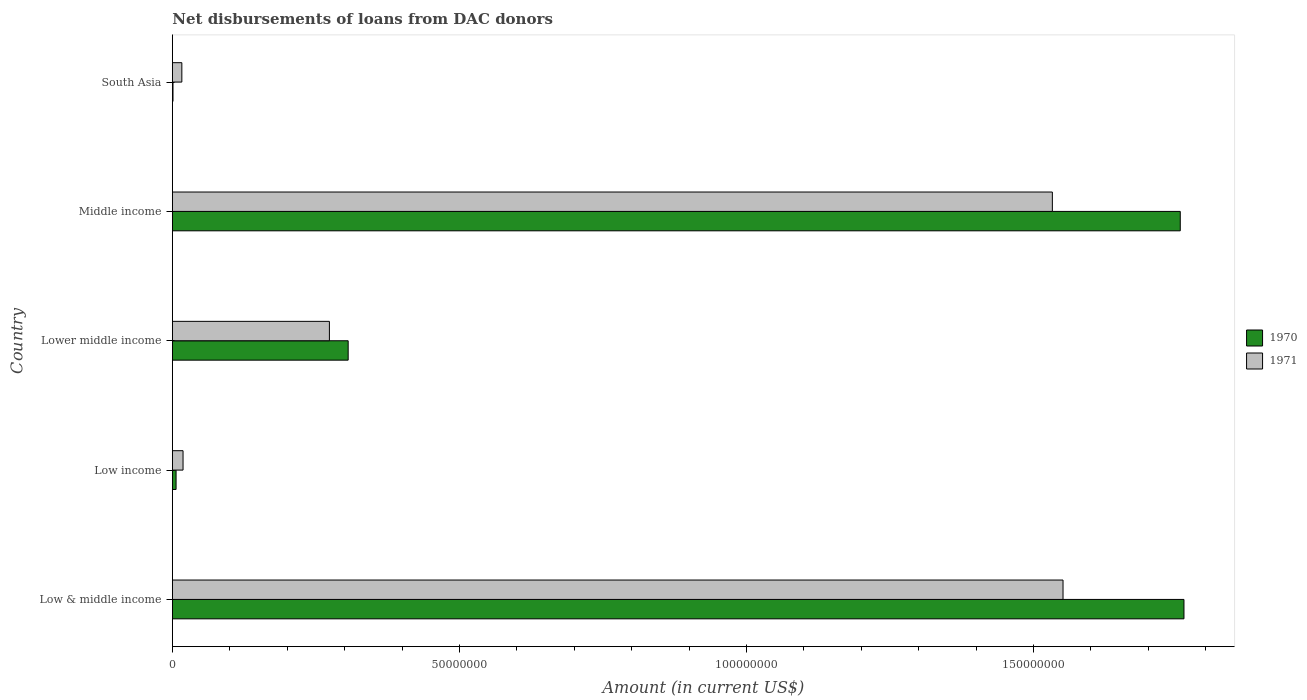How many different coloured bars are there?
Ensure brevity in your answer.  2. How many groups of bars are there?
Provide a short and direct response. 5. Are the number of bars per tick equal to the number of legend labels?
Provide a short and direct response. Yes. Are the number of bars on each tick of the Y-axis equal?
Your answer should be compact. Yes. What is the amount of loans disbursed in 1971 in South Asia?
Offer a very short reply. 1.65e+06. Across all countries, what is the maximum amount of loans disbursed in 1971?
Ensure brevity in your answer.  1.55e+08. Across all countries, what is the minimum amount of loans disbursed in 1971?
Give a very brief answer. 1.65e+06. In which country was the amount of loans disbursed in 1971 minimum?
Offer a terse response. South Asia. What is the total amount of loans disbursed in 1971 in the graph?
Your answer should be very brief. 3.39e+08. What is the difference between the amount of loans disbursed in 1971 in Low income and that in South Asia?
Offer a very short reply. 2.09e+05. What is the difference between the amount of loans disbursed in 1970 in South Asia and the amount of loans disbursed in 1971 in Lower middle income?
Make the answer very short. -2.72e+07. What is the average amount of loans disbursed in 1970 per country?
Offer a very short reply. 7.66e+07. What is the difference between the amount of loans disbursed in 1971 and amount of loans disbursed in 1970 in Lower middle income?
Offer a very short reply. -3.27e+06. In how many countries, is the amount of loans disbursed in 1971 greater than 40000000 US$?
Your response must be concise. 2. What is the ratio of the amount of loans disbursed in 1971 in Low income to that in Lower middle income?
Offer a terse response. 0.07. Is the amount of loans disbursed in 1970 in Lower middle income less than that in Middle income?
Your answer should be compact. Yes. Is the difference between the amount of loans disbursed in 1971 in Low & middle income and Middle income greater than the difference between the amount of loans disbursed in 1970 in Low & middle income and Middle income?
Give a very brief answer. Yes. What is the difference between the highest and the second highest amount of loans disbursed in 1971?
Provide a short and direct response. 1.86e+06. What is the difference between the highest and the lowest amount of loans disbursed in 1971?
Provide a short and direct response. 1.53e+08. In how many countries, is the amount of loans disbursed in 1970 greater than the average amount of loans disbursed in 1970 taken over all countries?
Keep it short and to the point. 2. What does the 2nd bar from the top in Low & middle income represents?
Make the answer very short. 1970. What does the 1st bar from the bottom in Low income represents?
Keep it short and to the point. 1970. How many bars are there?
Your answer should be very brief. 10. Are the values on the major ticks of X-axis written in scientific E-notation?
Your answer should be compact. No. Does the graph contain grids?
Your answer should be compact. No. Where does the legend appear in the graph?
Ensure brevity in your answer.  Center right. How are the legend labels stacked?
Make the answer very short. Vertical. What is the title of the graph?
Offer a very short reply. Net disbursements of loans from DAC donors. What is the label or title of the Y-axis?
Offer a very short reply. Country. What is the Amount (in current US$) of 1970 in Low & middle income?
Your answer should be compact. 1.76e+08. What is the Amount (in current US$) of 1971 in Low & middle income?
Your response must be concise. 1.55e+08. What is the Amount (in current US$) of 1970 in Low income?
Your response must be concise. 6.47e+05. What is the Amount (in current US$) of 1971 in Low income?
Provide a short and direct response. 1.86e+06. What is the Amount (in current US$) in 1970 in Lower middle income?
Offer a terse response. 3.06e+07. What is the Amount (in current US$) in 1971 in Lower middle income?
Your answer should be compact. 2.74e+07. What is the Amount (in current US$) of 1970 in Middle income?
Make the answer very short. 1.76e+08. What is the Amount (in current US$) in 1971 in Middle income?
Your answer should be very brief. 1.53e+08. What is the Amount (in current US$) of 1970 in South Asia?
Provide a succinct answer. 1.09e+05. What is the Amount (in current US$) in 1971 in South Asia?
Your response must be concise. 1.65e+06. Across all countries, what is the maximum Amount (in current US$) in 1970?
Your response must be concise. 1.76e+08. Across all countries, what is the maximum Amount (in current US$) of 1971?
Give a very brief answer. 1.55e+08. Across all countries, what is the minimum Amount (in current US$) of 1970?
Your response must be concise. 1.09e+05. Across all countries, what is the minimum Amount (in current US$) in 1971?
Your answer should be compact. 1.65e+06. What is the total Amount (in current US$) of 1970 in the graph?
Give a very brief answer. 3.83e+08. What is the total Amount (in current US$) in 1971 in the graph?
Provide a short and direct response. 3.39e+08. What is the difference between the Amount (in current US$) in 1970 in Low & middle income and that in Low income?
Ensure brevity in your answer.  1.76e+08. What is the difference between the Amount (in current US$) of 1971 in Low & middle income and that in Low income?
Your answer should be very brief. 1.53e+08. What is the difference between the Amount (in current US$) in 1970 in Low & middle income and that in Lower middle income?
Make the answer very short. 1.46e+08. What is the difference between the Amount (in current US$) of 1971 in Low & middle income and that in Lower middle income?
Keep it short and to the point. 1.28e+08. What is the difference between the Amount (in current US$) in 1970 in Low & middle income and that in Middle income?
Provide a succinct answer. 6.47e+05. What is the difference between the Amount (in current US$) in 1971 in Low & middle income and that in Middle income?
Keep it short and to the point. 1.86e+06. What is the difference between the Amount (in current US$) in 1970 in Low & middle income and that in South Asia?
Offer a very short reply. 1.76e+08. What is the difference between the Amount (in current US$) of 1971 in Low & middle income and that in South Asia?
Provide a succinct answer. 1.53e+08. What is the difference between the Amount (in current US$) in 1970 in Low income and that in Lower middle income?
Your response must be concise. -3.00e+07. What is the difference between the Amount (in current US$) in 1971 in Low income and that in Lower middle income?
Offer a terse response. -2.55e+07. What is the difference between the Amount (in current US$) in 1970 in Low income and that in Middle income?
Ensure brevity in your answer.  -1.75e+08. What is the difference between the Amount (in current US$) of 1971 in Low income and that in Middle income?
Give a very brief answer. -1.51e+08. What is the difference between the Amount (in current US$) of 1970 in Low income and that in South Asia?
Ensure brevity in your answer.  5.38e+05. What is the difference between the Amount (in current US$) of 1971 in Low income and that in South Asia?
Provide a short and direct response. 2.09e+05. What is the difference between the Amount (in current US$) in 1970 in Lower middle income and that in Middle income?
Offer a terse response. -1.45e+08. What is the difference between the Amount (in current US$) of 1971 in Lower middle income and that in Middle income?
Your answer should be compact. -1.26e+08. What is the difference between the Amount (in current US$) of 1970 in Lower middle income and that in South Asia?
Offer a very short reply. 3.05e+07. What is the difference between the Amount (in current US$) of 1971 in Lower middle income and that in South Asia?
Your answer should be very brief. 2.57e+07. What is the difference between the Amount (in current US$) in 1970 in Middle income and that in South Asia?
Offer a terse response. 1.75e+08. What is the difference between the Amount (in current US$) in 1971 in Middle income and that in South Asia?
Offer a very short reply. 1.52e+08. What is the difference between the Amount (in current US$) of 1970 in Low & middle income and the Amount (in current US$) of 1971 in Low income?
Provide a succinct answer. 1.74e+08. What is the difference between the Amount (in current US$) of 1970 in Low & middle income and the Amount (in current US$) of 1971 in Lower middle income?
Provide a succinct answer. 1.49e+08. What is the difference between the Amount (in current US$) in 1970 in Low & middle income and the Amount (in current US$) in 1971 in Middle income?
Keep it short and to the point. 2.29e+07. What is the difference between the Amount (in current US$) of 1970 in Low & middle income and the Amount (in current US$) of 1971 in South Asia?
Ensure brevity in your answer.  1.75e+08. What is the difference between the Amount (in current US$) in 1970 in Low income and the Amount (in current US$) in 1971 in Lower middle income?
Provide a short and direct response. -2.67e+07. What is the difference between the Amount (in current US$) of 1970 in Low income and the Amount (in current US$) of 1971 in Middle income?
Offer a terse response. -1.53e+08. What is the difference between the Amount (in current US$) in 1970 in Low income and the Amount (in current US$) in 1971 in South Asia?
Offer a very short reply. -1.00e+06. What is the difference between the Amount (in current US$) of 1970 in Lower middle income and the Amount (in current US$) of 1971 in Middle income?
Offer a terse response. -1.23e+08. What is the difference between the Amount (in current US$) of 1970 in Lower middle income and the Amount (in current US$) of 1971 in South Asia?
Give a very brief answer. 2.90e+07. What is the difference between the Amount (in current US$) in 1970 in Middle income and the Amount (in current US$) in 1971 in South Asia?
Offer a very short reply. 1.74e+08. What is the average Amount (in current US$) in 1970 per country?
Your answer should be compact. 7.66e+07. What is the average Amount (in current US$) of 1971 per country?
Your answer should be compact. 6.79e+07. What is the difference between the Amount (in current US$) of 1970 and Amount (in current US$) of 1971 in Low & middle income?
Ensure brevity in your answer.  2.11e+07. What is the difference between the Amount (in current US$) of 1970 and Amount (in current US$) of 1971 in Low income?
Ensure brevity in your answer.  -1.21e+06. What is the difference between the Amount (in current US$) of 1970 and Amount (in current US$) of 1971 in Lower middle income?
Provide a short and direct response. 3.27e+06. What is the difference between the Amount (in current US$) of 1970 and Amount (in current US$) of 1971 in Middle income?
Your answer should be very brief. 2.23e+07. What is the difference between the Amount (in current US$) of 1970 and Amount (in current US$) of 1971 in South Asia?
Provide a short and direct response. -1.54e+06. What is the ratio of the Amount (in current US$) of 1970 in Low & middle income to that in Low income?
Offer a terse response. 272.33. What is the ratio of the Amount (in current US$) in 1971 in Low & middle income to that in Low income?
Make the answer very short. 83.45. What is the ratio of the Amount (in current US$) of 1970 in Low & middle income to that in Lower middle income?
Ensure brevity in your answer.  5.75. What is the ratio of the Amount (in current US$) of 1971 in Low & middle income to that in Lower middle income?
Your response must be concise. 5.67. What is the ratio of the Amount (in current US$) of 1970 in Low & middle income to that in Middle income?
Offer a terse response. 1. What is the ratio of the Amount (in current US$) in 1971 in Low & middle income to that in Middle income?
Give a very brief answer. 1.01. What is the ratio of the Amount (in current US$) in 1970 in Low & middle income to that in South Asia?
Your answer should be very brief. 1616.51. What is the ratio of the Amount (in current US$) of 1971 in Low & middle income to that in South Asia?
Your answer should be very brief. 94.02. What is the ratio of the Amount (in current US$) in 1970 in Low income to that in Lower middle income?
Make the answer very short. 0.02. What is the ratio of the Amount (in current US$) in 1971 in Low income to that in Lower middle income?
Your answer should be very brief. 0.07. What is the ratio of the Amount (in current US$) of 1970 in Low income to that in Middle income?
Ensure brevity in your answer.  0. What is the ratio of the Amount (in current US$) of 1971 in Low income to that in Middle income?
Offer a terse response. 0.01. What is the ratio of the Amount (in current US$) in 1970 in Low income to that in South Asia?
Provide a short and direct response. 5.94. What is the ratio of the Amount (in current US$) of 1971 in Low income to that in South Asia?
Make the answer very short. 1.13. What is the ratio of the Amount (in current US$) of 1970 in Lower middle income to that in Middle income?
Provide a short and direct response. 0.17. What is the ratio of the Amount (in current US$) in 1971 in Lower middle income to that in Middle income?
Keep it short and to the point. 0.18. What is the ratio of the Amount (in current US$) in 1970 in Lower middle income to that in South Asia?
Your response must be concise. 280.94. What is the ratio of the Amount (in current US$) of 1971 in Lower middle income to that in South Asia?
Give a very brief answer. 16.58. What is the ratio of the Amount (in current US$) in 1970 in Middle income to that in South Asia?
Keep it short and to the point. 1610.58. What is the ratio of the Amount (in current US$) in 1971 in Middle income to that in South Asia?
Give a very brief answer. 92.89. What is the difference between the highest and the second highest Amount (in current US$) in 1970?
Make the answer very short. 6.47e+05. What is the difference between the highest and the second highest Amount (in current US$) in 1971?
Provide a succinct answer. 1.86e+06. What is the difference between the highest and the lowest Amount (in current US$) of 1970?
Your response must be concise. 1.76e+08. What is the difference between the highest and the lowest Amount (in current US$) of 1971?
Your answer should be compact. 1.53e+08. 